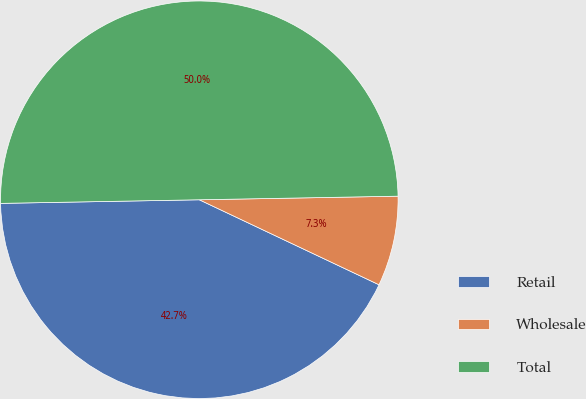<chart> <loc_0><loc_0><loc_500><loc_500><pie_chart><fcel>Retail<fcel>Wholesale<fcel>Total<nl><fcel>42.68%<fcel>7.32%<fcel>50.0%<nl></chart> 